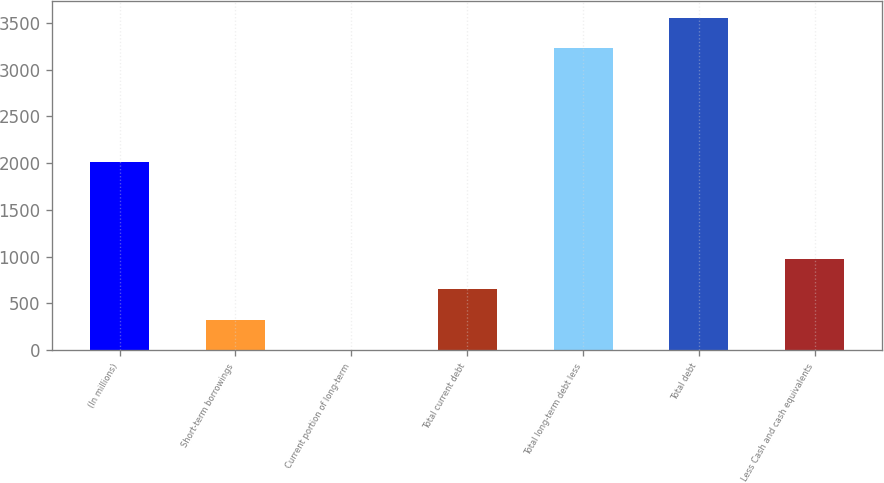<chart> <loc_0><loc_0><loc_500><loc_500><bar_chart><fcel>(In millions)<fcel>Short-term borrowings<fcel>Current portion of long-term<fcel>Total current debt<fcel>Total long-term debt less<fcel>Total debt<fcel>Less Cash and cash equivalents<nl><fcel>2017<fcel>327.78<fcel>2.2<fcel>653.36<fcel>3230.5<fcel>3556.08<fcel>978.94<nl></chart> 